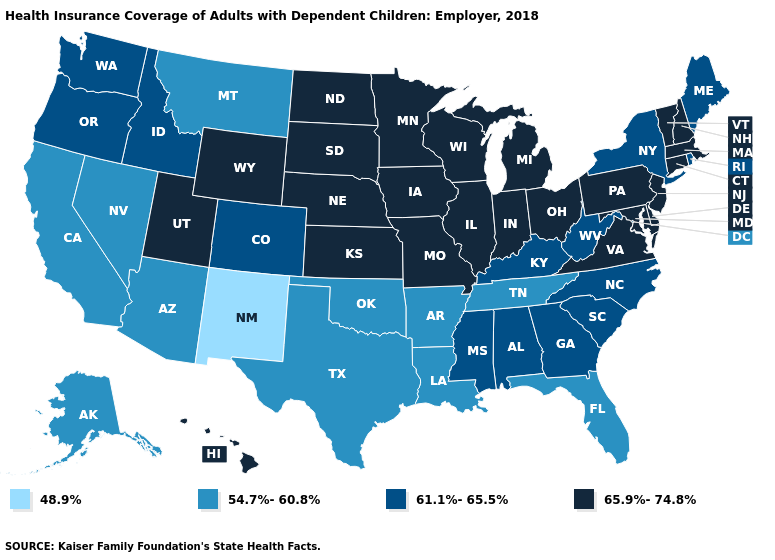What is the highest value in states that border Virginia?
Answer briefly. 65.9%-74.8%. Which states have the lowest value in the USA?
Be succinct. New Mexico. Which states have the lowest value in the USA?
Give a very brief answer. New Mexico. What is the lowest value in the USA?
Answer briefly. 48.9%. Among the states that border Connecticut , which have the lowest value?
Give a very brief answer. New York, Rhode Island. What is the value of Mississippi?
Short answer required. 61.1%-65.5%. Name the states that have a value in the range 54.7%-60.8%?
Keep it brief. Alaska, Arizona, Arkansas, California, Florida, Louisiana, Montana, Nevada, Oklahoma, Tennessee, Texas. What is the value of Maryland?
Write a very short answer. 65.9%-74.8%. Does Arkansas have a lower value than Idaho?
Answer briefly. Yes. What is the value of New Hampshire?
Write a very short answer. 65.9%-74.8%. What is the value of New York?
Quick response, please. 61.1%-65.5%. Among the states that border Nebraska , does Wyoming have the highest value?
Give a very brief answer. Yes. Does Illinois have the lowest value in the USA?
Short answer required. No. What is the value of Alaska?
Give a very brief answer. 54.7%-60.8%. What is the value of Georgia?
Quick response, please. 61.1%-65.5%. 